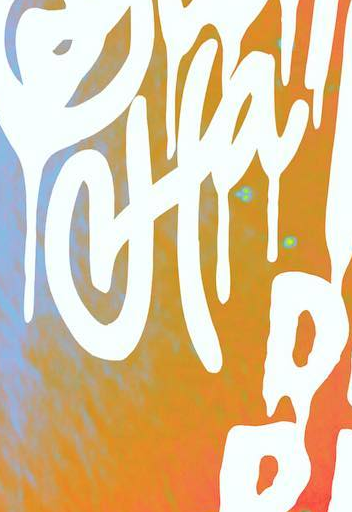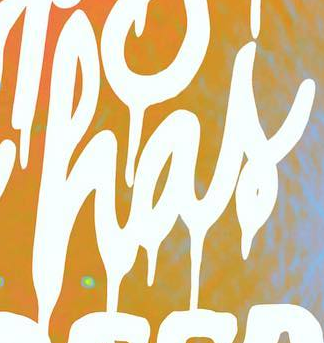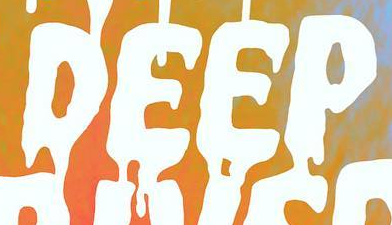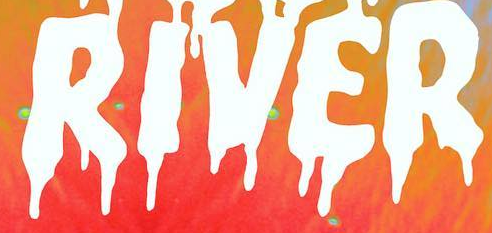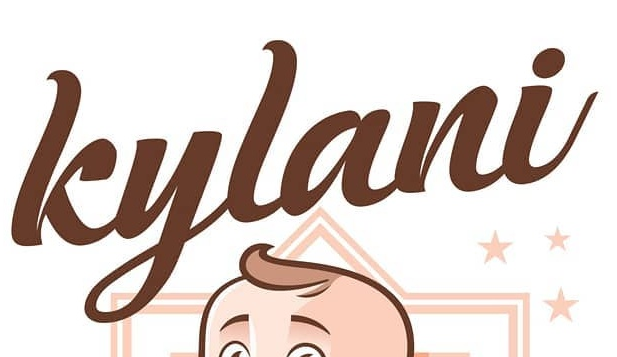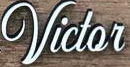Transcribe the words shown in these images in order, separated by a semicolon. Ha; has; DEEP; RIVER; kylani; Victor 